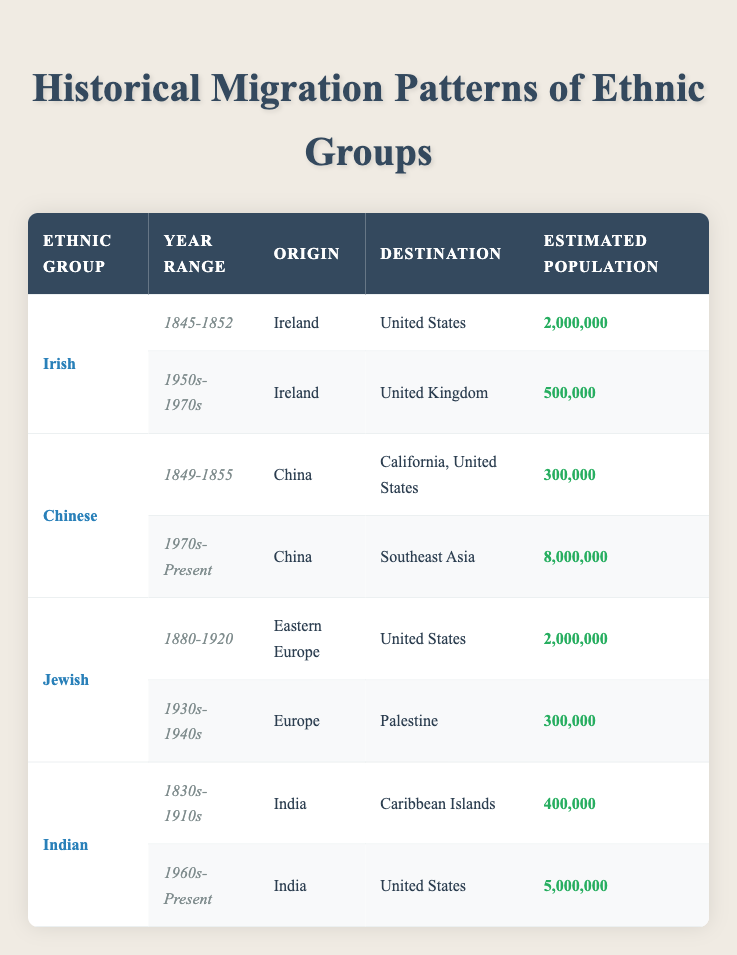What was the estimated population of Irish migrants to the United States between 1845-1852? The table shows that the estimated population of Irish migrants to the United States during the year range 1845-1852 was 2,000,000.
Answer: 2,000,000 What is the total estimated population of Chinese migrants to California and Southeast Asia? From the table, the estimated population of Chinese migrants to California (1849-1855) is 300,000 and to Southeast Asia (1970s-Present) is 8,000,000. Adding these two populations gives 300,000 + 8,000,000 = 8,300,000.
Answer: 8,300,000 Did any Indian migrants arrive in the Caribbean Islands between 1830s and 1910s? Yes, according to the table, the estimated population of Indian migrants to the Caribbean Islands during that time range is listed as 400,000.
Answer: Yes Which ethnic group had the highest estimated migration population to the United States in the 1900s? Analyzing the table, both the Irish and Jewish ethnic groups had an estimated population of 2,000,000 migrants to the United States. Since they are equal, we conclude that both had the highest population for that time period in the table.
Answer: Irish and Jewish What is the range of estimated population for Indian migrations from the Caribbean Islands to the United States? The table lists 400,000 for Indian migrants to the Caribbean Islands (1830s-1910s) and 5,000,000 for those migrating to the United States (1960s-Present). The range is from 400,000 to 5,000,000.
Answer: 400,000 to 5,000,000 Which ethnic group has the lowest estimated population in their migration data? By examining the estimated populations, the Chinese migration to California (300,000) is the lowest compared to others in the table. Therefore, the Chinese group has the lowest estimated population in their migration data.
Answer: Chinese What time period saw the migration of 5,000,000 Indians to the United States? According to the table, the Indian migration to the United States with an estimated population of 5,000,000 occurred during the time range of 1960s-Present.
Answer: 1960s-Present Are there any migrations from Europe to Palestine recorded in the 1930s-1940s? Yes, the table indicates there was a migration from Europe to Palestine recorded in the year range of 1930s-1940s with an estimated population of 300,000.
Answer: Yes What is the difference in estimated population between Irish migrants to the United States and Indian migrants to the United States? The Irish migrants to the United States had an estimated population of 2,000,000, while Indian migrants to the United States had 5,000,000. Calculating the difference gives 5,000,000 - 2,000,000 = 3,000,000.
Answer: 3,000,000 